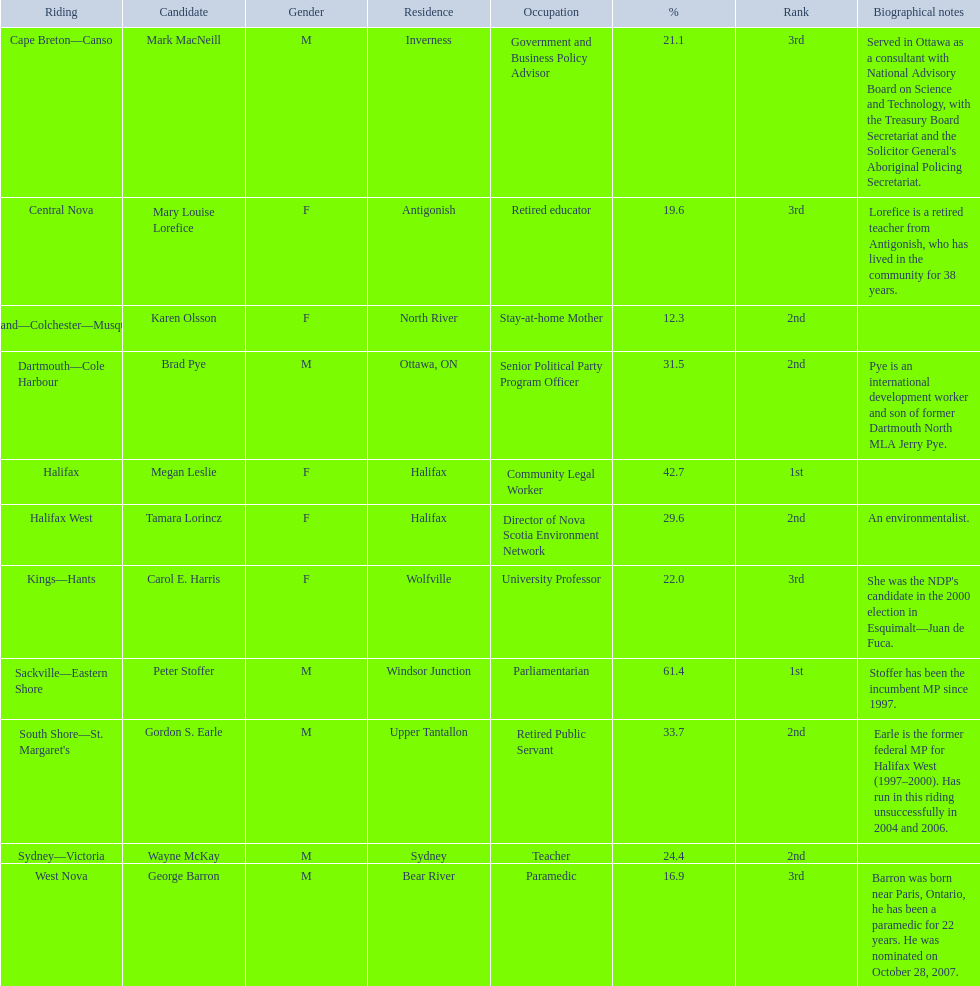Who were all of the new democratic party candidates during the 2008 canadian federal election? Mark MacNeill, Mary Louise Lorefice, Karen Olsson, Brad Pye, Megan Leslie, Tamara Lorincz, Carol E. Harris, Peter Stoffer, Gordon S. Earle, Wayne McKay, George Barron. And between mark macneill and karen olsson, which candidate received more votes? Mark MacNeill. 